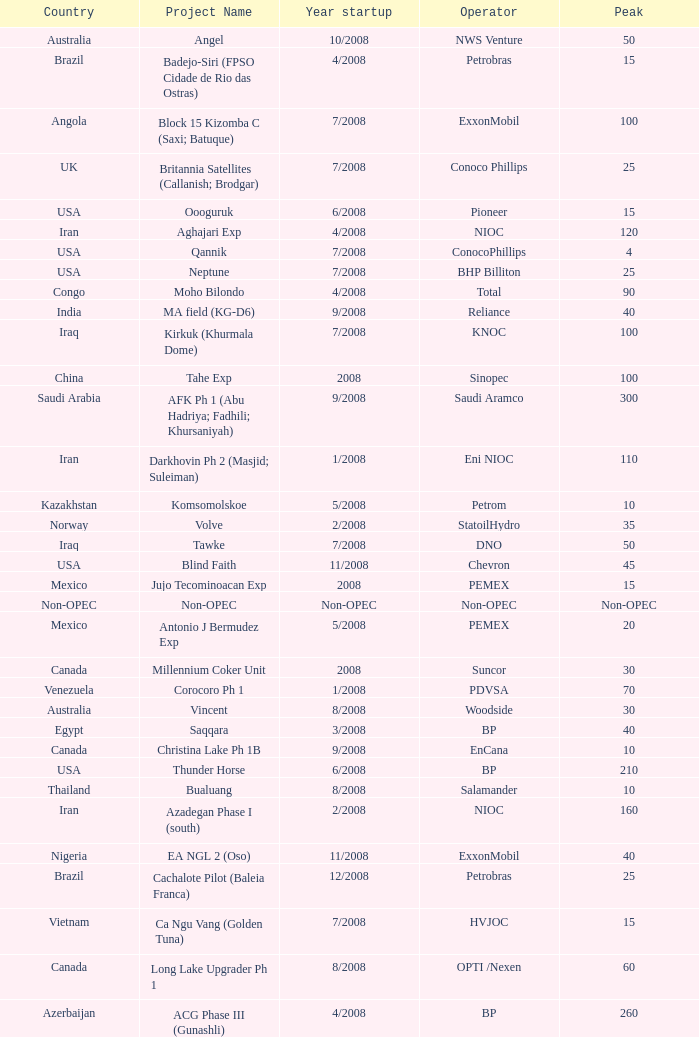Write the full table. {'header': ['Country', 'Project Name', 'Year startup', 'Operator', 'Peak'], 'rows': [['Australia', 'Angel', '10/2008', 'NWS Venture', '50'], ['Brazil', 'Badejo-Siri (FPSO Cidade de Rio das Ostras)', '4/2008', 'Petrobras', '15'], ['Angola', 'Block 15 Kizomba C (Saxi; Batuque)', '7/2008', 'ExxonMobil', '100'], ['UK', 'Britannia Satellites (Callanish; Brodgar)', '7/2008', 'Conoco Phillips', '25'], ['USA', 'Oooguruk', '6/2008', 'Pioneer', '15'], ['Iran', 'Aghajari Exp', '4/2008', 'NIOC', '120'], ['USA', 'Qannik', '7/2008', 'ConocoPhillips', '4'], ['USA', 'Neptune', '7/2008', 'BHP Billiton', '25'], ['Congo', 'Moho Bilondo', '4/2008', 'Total', '90'], ['India', 'MA field (KG-D6)', '9/2008', 'Reliance', '40'], ['Iraq', 'Kirkuk (Khurmala Dome)', '7/2008', 'KNOC', '100'], ['China', 'Tahe Exp', '2008', 'Sinopec', '100'], ['Saudi Arabia', 'AFK Ph 1 (Abu Hadriya; Fadhili; Khursaniyah)', '9/2008', 'Saudi Aramco', '300'], ['Iran', 'Darkhovin Ph 2 (Masjid; Suleiman)', '1/2008', 'Eni NIOC', '110'], ['Kazakhstan', 'Komsomolskoe', '5/2008', 'Petrom', '10'], ['Norway', 'Volve', '2/2008', 'StatoilHydro', '35'], ['Iraq', 'Tawke', '7/2008', 'DNO', '50'], ['USA', 'Blind Faith', '11/2008', 'Chevron', '45'], ['Mexico', 'Jujo Tecominoacan Exp', '2008', 'PEMEX', '15'], ['Non-OPEC', 'Non-OPEC', 'Non-OPEC', 'Non-OPEC', 'Non-OPEC'], ['Mexico', 'Antonio J Bermudez Exp', '5/2008', 'PEMEX', '20'], ['Canada', 'Millennium Coker Unit', '2008', 'Suncor', '30'], ['Venezuela', 'Corocoro Ph 1', '1/2008', 'PDVSA', '70'], ['Australia', 'Vincent', '8/2008', 'Woodside', '30'], ['Egypt', 'Saqqara', '3/2008', 'BP', '40'], ['Canada', 'Christina Lake Ph 1B', '9/2008', 'EnCana', '10'], ['USA', 'Thunder Horse', '6/2008', 'BP', '210'], ['Thailand', 'Bualuang', '8/2008', 'Salamander', '10'], ['Iran', 'Azadegan Phase I (south)', '2/2008', 'NIOC', '160'], ['Nigeria', 'EA NGL 2 (Oso)', '11/2008', 'ExxonMobil', '40'], ['Brazil', 'Cachalote Pilot (Baleia Franca)', '12/2008', 'Petrobras', '25'], ['Vietnam', 'Ca Ngu Vang (Golden Tuna)', '7/2008', 'HVJOC', '15'], ['Canada', 'Long Lake Upgrader Ph 1', '8/2008', 'OPTI /Nexen', '60'], ['Azerbaijan', 'ACG Phase III (Gunashli)', '4/2008', 'BP', '260'], ['Canada', 'Horizon Oil Sands Project (Phase I)', '12/2008', 'CNRL', '110'], ['Oman', 'Mukhaizna EOR Ph 1', '2008', 'Occidental', '40'], ['Iran', 'South Pars phase 6-7-8', '10/2008', 'Statoil', '180'], ['Brazil', 'Marlim Leste P-53', '11/2008', 'Petrobras', '180'], ['Mexico', 'Ixtal Manik', '2008', 'PEMEX', '55'], ['OPEC', 'OPEC', 'OPEC', 'OPEC', 'OPEC'], ['USA', 'Ursa Princess Exp', '1/2008', 'Shell', '30'], ['Canada', 'Christina Lake Ph 2', '8/2008', 'MEG Energy (CNOOC interest)', '20'], ['Indonesia', 'North Duri Area 12', '11/2008', 'Chevron', '34'], ['Mexico', 'Bellota Chinchorro Exp', '5/2008', 'PEMEX', '20'], ['Canada', 'Jackfish Ph 1', '3/2008', 'Devon Energy', '30'], ['Kuwait', 'Project Kuwait Phase I', '12/2008', 'KOC', '50'], ['China', 'Xijiang 23-1', '6/2008', 'CNOOC', '40'], ['Mexico', '( Chicontepec ) Exp 1', '2008', 'PEMEX', '200'], ['Philippines', 'Galoc', '10/2008', 'GPC', '15'], ['Kazakhstan', 'Dunga', '3/2008', 'Maersk', '150'], ['Vietnam', 'Su Tu Vang', '10/2008', 'Cuu Long Joint', '40'], ['Russia', 'Talakan Ph 1', '10/2008', 'Surgutneftegaz', '60'], ['Nigeria', 'Agbami', '7/2008', 'Chevron', '230'], ['Saudi Arabia', 'Hawiyah', '9/2008', 'Saudi Aramco', '310'], ['Russia', 'Verkhnechonsk Ph 1 (early oil)', '10/2008', 'TNK-BP Rosneft', '20'], ['Angola', 'Block 15 Kizomba C (Mondo)', '1/2008', 'ExxonMobil', '100'], ['Nigeria', 'EA expansion', '11/2008', 'Shell', '80'], ['Norway', 'Alvheim; Volund; Vilje', '6/2008', 'Marathon', '100'], ['China', 'Erdos CTL Ph 1', '10/2008', 'Shenhua', '20'], ['Russia', 'Yuzhno-Khylchuyuskoye "YK" Ph 1', '8/2008', 'Lukoil ConocoPhillips', '75'], ['Vietnam', 'Song Doc', '12/2008', 'Talisman', '10'], ['China', 'Wenchang Exp', '7/2008', 'CNOOC', '40']]} What is the Operator with a Peak that is 55? PEMEX. 